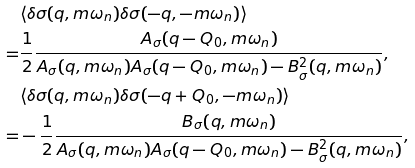Convert formula to latex. <formula><loc_0><loc_0><loc_500><loc_500>& \langle \delta \sigma ( q , \i m \omega _ { n } ) \delta \sigma ( - q , - \i m \omega _ { n } ) \rangle \\ = & \frac { 1 } { 2 } \frac { A _ { \sigma } ( q - Q _ { 0 } , \i m \omega _ { n } ) } { A _ { \sigma } ( q , \i m \omega _ { n } ) A _ { \sigma } ( q - Q _ { 0 } , \i m \omega _ { n } ) - B _ { \sigma } ^ { 2 } ( q , \i m \omega _ { n } ) } , \\ & \langle \delta \sigma ( q , \i m \omega _ { n } ) \delta \sigma ( - q + Q _ { 0 } , - \i m \omega _ { n } ) \rangle \\ = & - \frac { 1 } { 2 } \frac { B _ { \sigma } ( q , \i m \omega _ { n } ) } { A _ { \sigma } ( q , \i m \omega _ { n } ) A _ { \sigma } ( q - Q _ { 0 } , \i m \omega _ { n } ) - B _ { \sigma } ^ { 2 } ( q , \i m \omega _ { n } ) } ,</formula> 